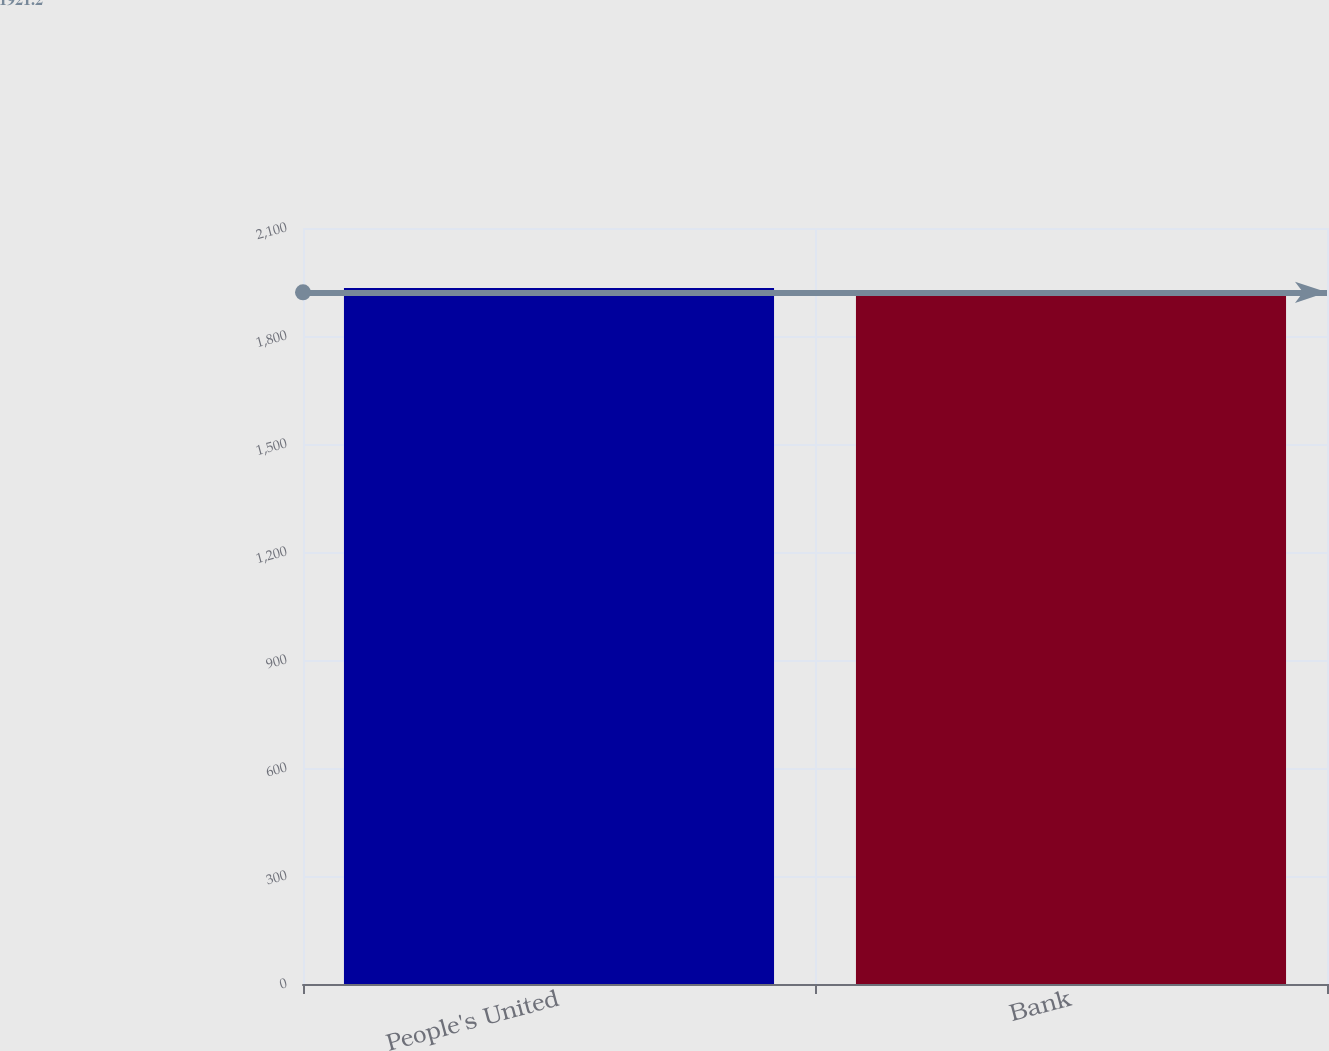Convert chart to OTSL. <chart><loc_0><loc_0><loc_500><loc_500><bar_chart><fcel>People's United<fcel>Bank<nl><fcel>1933.4<fcel>1921.2<nl></chart> 